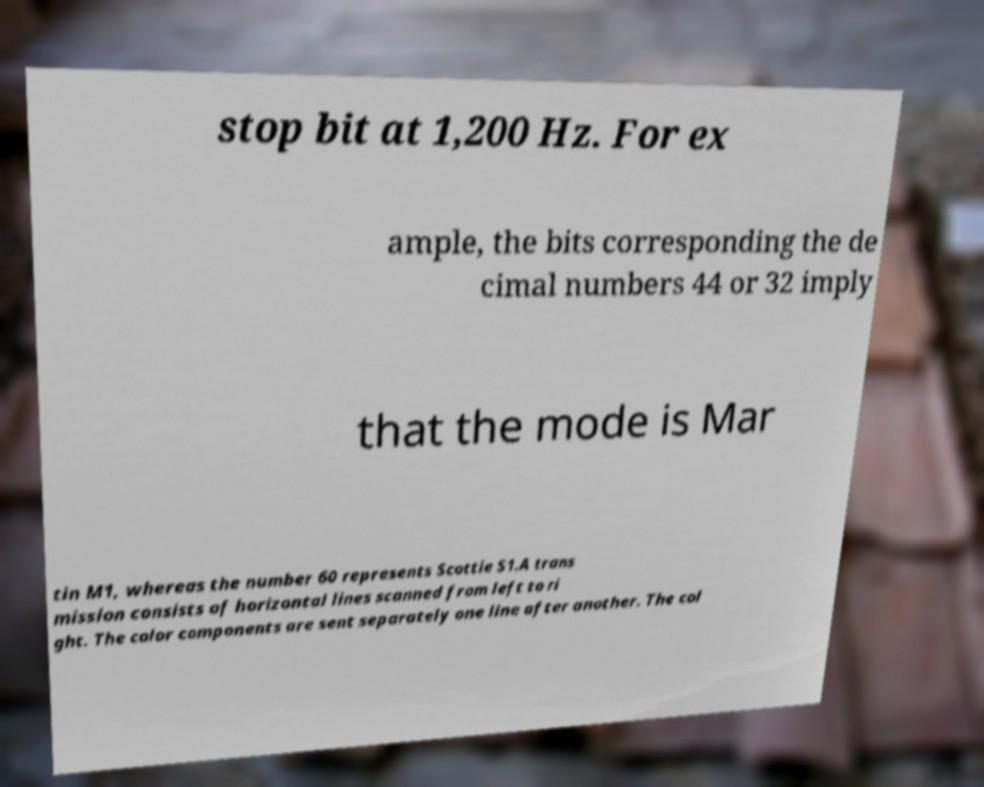What messages or text are displayed in this image? I need them in a readable, typed format. stop bit at 1,200 Hz. For ex ample, the bits corresponding the de cimal numbers 44 or 32 imply that the mode is Mar tin M1, whereas the number 60 represents Scottie S1.A trans mission consists of horizontal lines scanned from left to ri ght. The color components are sent separately one line after another. The col 